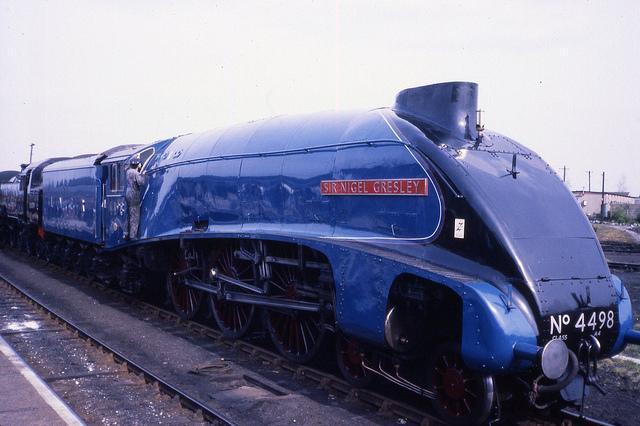How many people are around?
Give a very brief answer. 1. 